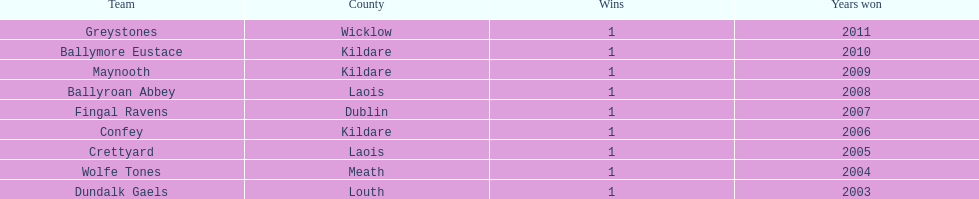What is the years won for each team 2011, 2010, 2009, 2008, 2007, 2006, 2005, 2004, 2003. 